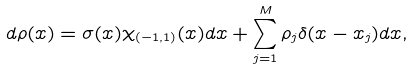Convert formula to latex. <formula><loc_0><loc_0><loc_500><loc_500>d \rho ( x ) = \sigma ( x ) \chi _ { ( - 1 , 1 ) } ( x ) d x + \sum _ { j = 1 } ^ { M } \rho _ { j } \delta ( x - x _ { j } ) d x ,</formula> 